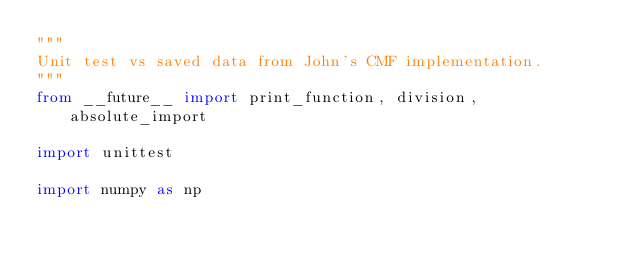Convert code to text. <code><loc_0><loc_0><loc_500><loc_500><_Python_>"""
Unit test vs saved data from John's CMF implementation.
"""
from __future__ import print_function, division, absolute_import

import unittest

import numpy as np
</code> 